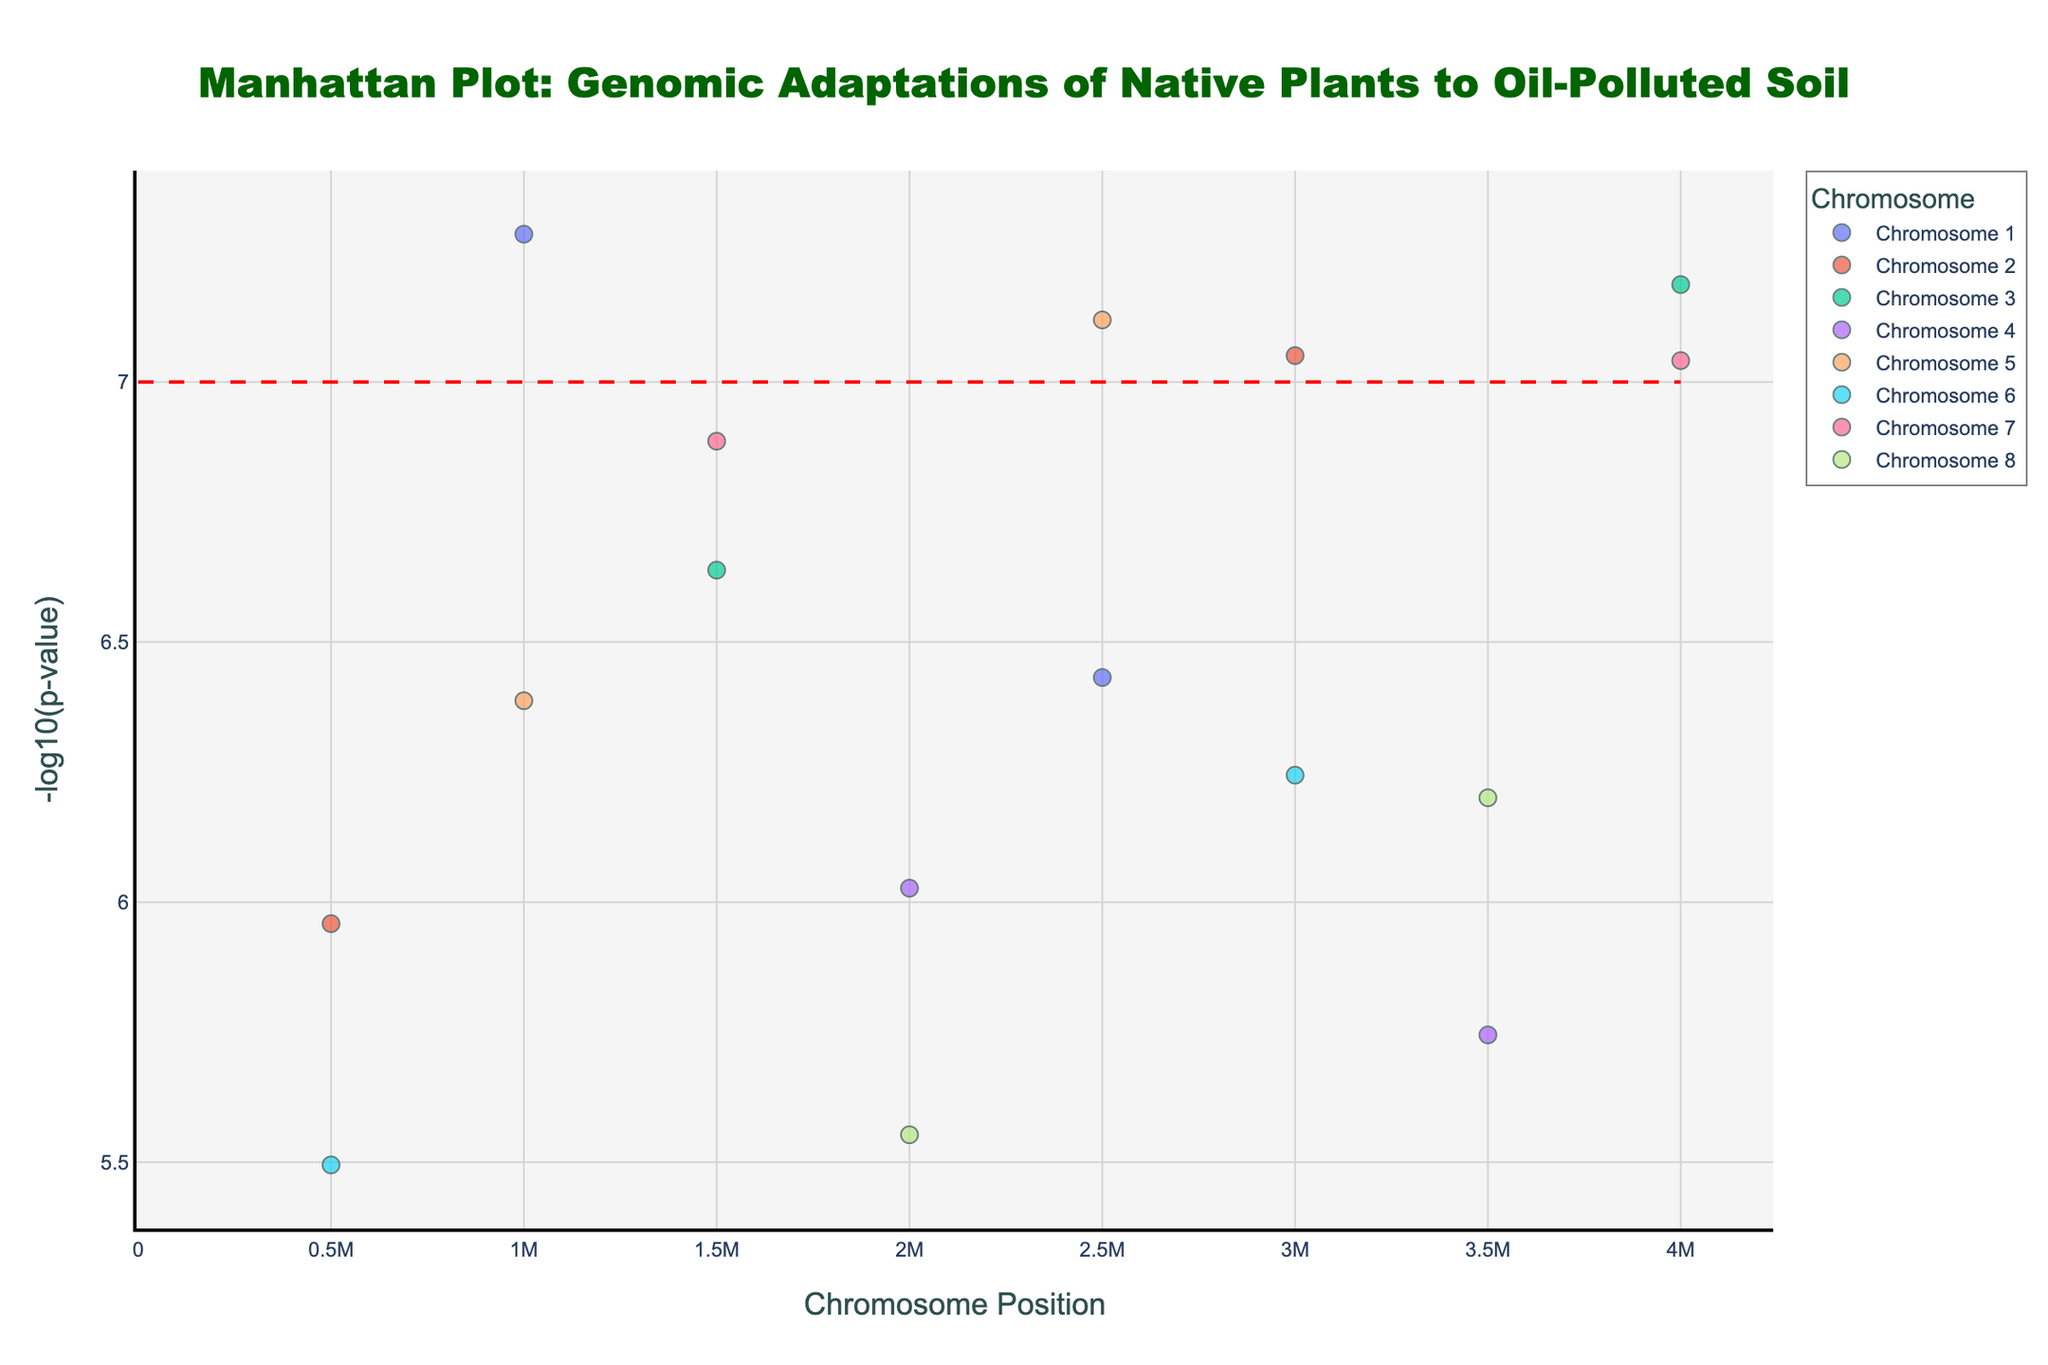How many chromosomes are represented in the figure? Count the number of unique chromosomes indicated in the legend. The legend shows Chromosome 1 to Chromosome 8, making it a total of 8 chromosomes.
Answer: 8 Which chromosome has the most significant p-value observed? The most significant p-value is indicated by the highest -log10(p-value) on the y-axis. The highest point is on Chromosome 1.
Answer: Chromosome 1 What is the plant species associated with the most significant p-value on Chromosome 1? Hover over the highest data point on Chromosome 1. The tooltip shows the plant species and location, which is Spartina alterniflora from the Gulf of Mexico Coast.
Answer: Spartina alterniflora Which chromosome has no p-value below the significance threshold line? The significance threshold line is at y=7. Chromosome 4 has no points above this line.
Answer: Chromosome 4 Are there any data points from Chromosome 5 that are above the significance threshold? Check the data points on Chromosome 5. Both Typha latifolia and Phragmites australis have points above the y=7 line.
Answer: Yes What is the y-axis representing? Read the y-axis title. It indicates '-log10(p-value)'.
Answer: -log10(p-value) What is the range of chromosome positions shown on the x-axis? Observe the lowest and highest values on the x-axis. The positions range from 0 to approximately 4000000.
Answer: 0 to 4000000 Which location is associated with the plant species on Chromosome 3 with the second-highest p-value? Find the second-highest point on Chromosome 3 and use the tooltip to identify the location. The second highest point corresponds to Salicornia bigelovii from the Texas Gulf Coast.
Answer: Texas Gulf Coast What is the median p-value for the data points on Chromosome 7? Convert the -log10(p-value) values back to actual p-values for Chromosome 7, then calculate the median. Points are Bacopa monnieri (1.3e-7) and Sesuvium portulacastrum (9.1e-8). Median of [1.3e-7, 9.1e-8] = (1.3e-7 + 9.1e-8)/2 = 1.105e-7
Answer: 1.105e-7 